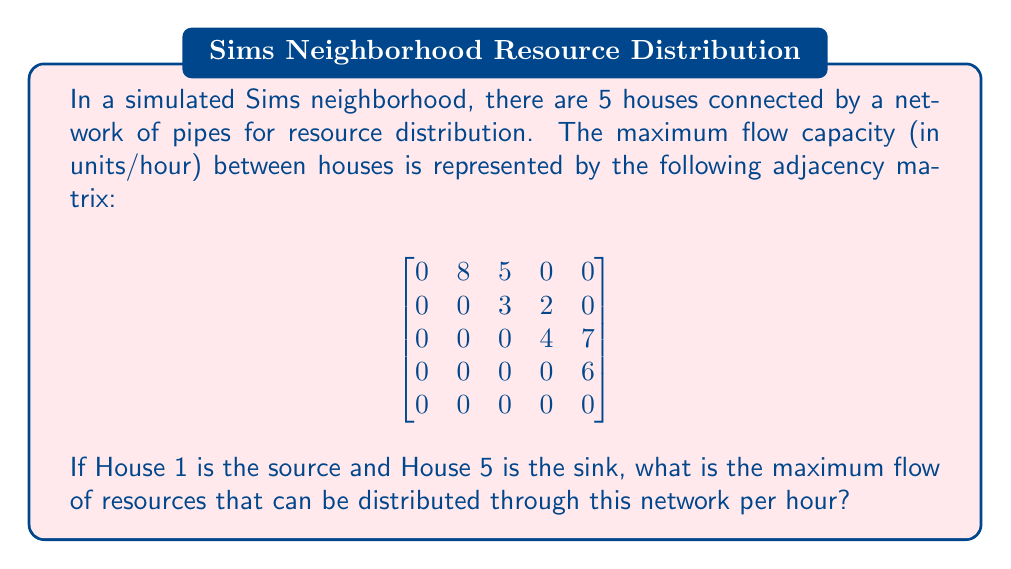Can you solve this math problem? To solve this problem, we'll use the Ford-Fulkerson algorithm to find the maximum flow in the network:

1) First, let's visualize the network:

[asy]
import graph;

size(200);

pair[] nodes = {(0,0), (2,1), (2,-1), (4,1), (6,0)};
for(int i=0; i<5; ++i) {
  dot(nodes[i]);
  label("H" + string(i+1), nodes[i], align=E);
}

draw(nodes[0]--nodes[1], arrow=Arrow(), L="8");
draw(nodes[0]--nodes[2], arrow=Arrow(), L="5");
draw(nodes[1]--nodes[2], arrow=Arrow(), L="3");
draw(nodes[1]--nodes[3], arrow=Arrow(), L="2");
draw(nodes[2]--nodes[3], arrow=Arrow(), L="4");
draw(nodes[2]--nodes[4], arrow=Arrow(), L="7");
draw(nodes[3]--nodes[4], arrow=Arrow(), L="6");
[/asy]

2) We'll find augmenting paths and their bottleneck capacities:

   Path 1: H1 -> H2 -> H4 -> H5
   Bottleneck: min(8, 2, 6) = 2
   Flow: 2

   Path 2: H1 -> H3 -> H5
   Bottleneck: min(5, 7) = 5
   Flow: 5

   Path 3: H1 -> H2 -> H3 -> H5
   Bottleneck: min(6, 3, 2) = 2
   Flow: 2

3) After these paths, we can't find any more augmenting paths from H1 to H5.

4) The maximum flow is the sum of the flows through all augmenting paths:
   
   $2 + 5 + 2 = 9$

Therefore, the maximum flow of resources that can be distributed through this network per hour is 9 units/hour.
Answer: 9 units/hour 